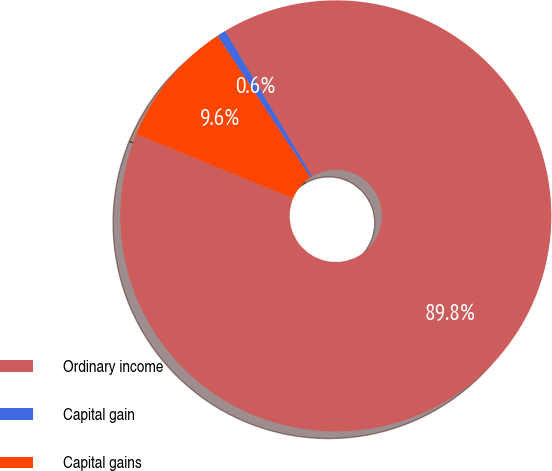Convert chart. <chart><loc_0><loc_0><loc_500><loc_500><pie_chart><fcel>Ordinary income<fcel>Capital gain<fcel>Capital gains<nl><fcel>89.78%<fcel>0.65%<fcel>9.57%<nl></chart> 